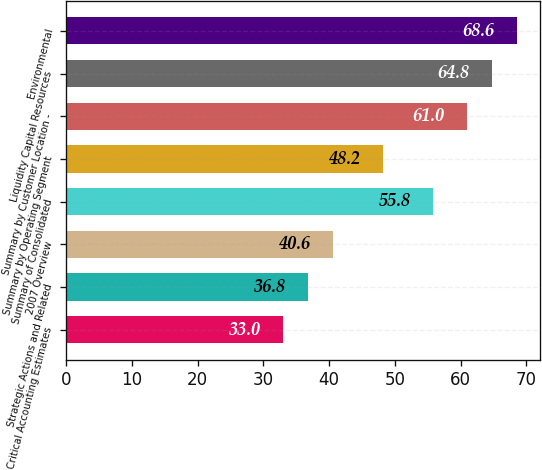<chart> <loc_0><loc_0><loc_500><loc_500><bar_chart><fcel>Critical Accounting Estimates<fcel>Strategic Actions and Related<fcel>2007 Overview<fcel>Summary of Consolidated<fcel>Summary by Operating Segment<fcel>Summary by Customer Location -<fcel>Liquidity Capital Resources<fcel>Environmental<nl><fcel>33<fcel>36.8<fcel>40.6<fcel>55.8<fcel>48.2<fcel>61<fcel>64.8<fcel>68.6<nl></chart> 